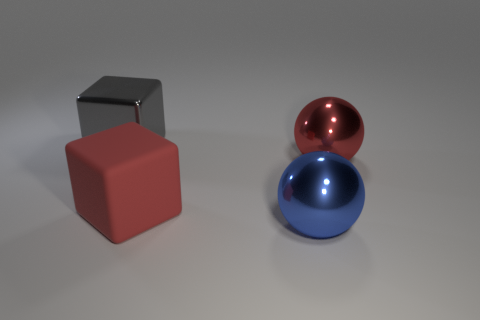Is the number of large blue metal spheres that are to the left of the large red metal ball the same as the number of big blue spheres?
Make the answer very short. Yes. What number of large metallic objects are behind the rubber block and right of the large red rubber object?
Offer a very short reply. 1. Is the shape of the big metallic object in front of the rubber block the same as  the red shiny thing?
Your answer should be very brief. Yes. What material is the other cube that is the same size as the gray shiny block?
Provide a succinct answer. Rubber. Are there an equal number of red objects that are behind the red metallic thing and red blocks to the right of the big metal block?
Your answer should be compact. No. What number of red objects are in front of the large sphere in front of the cube that is right of the large gray cube?
Make the answer very short. 0. There is a rubber object; does it have the same color as the ball behind the red rubber cube?
Your answer should be very brief. Yes. There is a red sphere that is made of the same material as the gray cube; what size is it?
Offer a very short reply. Large. Are there more shiny spheres on the right side of the blue metal object than small yellow cylinders?
Offer a very short reply. Yes. The large ball behind the metal object that is in front of the red object on the right side of the big blue object is made of what material?
Provide a succinct answer. Metal. 